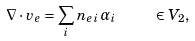<formula> <loc_0><loc_0><loc_500><loc_500>\nabla \cdot v _ { e } = \sum _ { i } n _ { e \, i } \alpha _ { i } \quad \ \in V _ { 2 } ,</formula> 